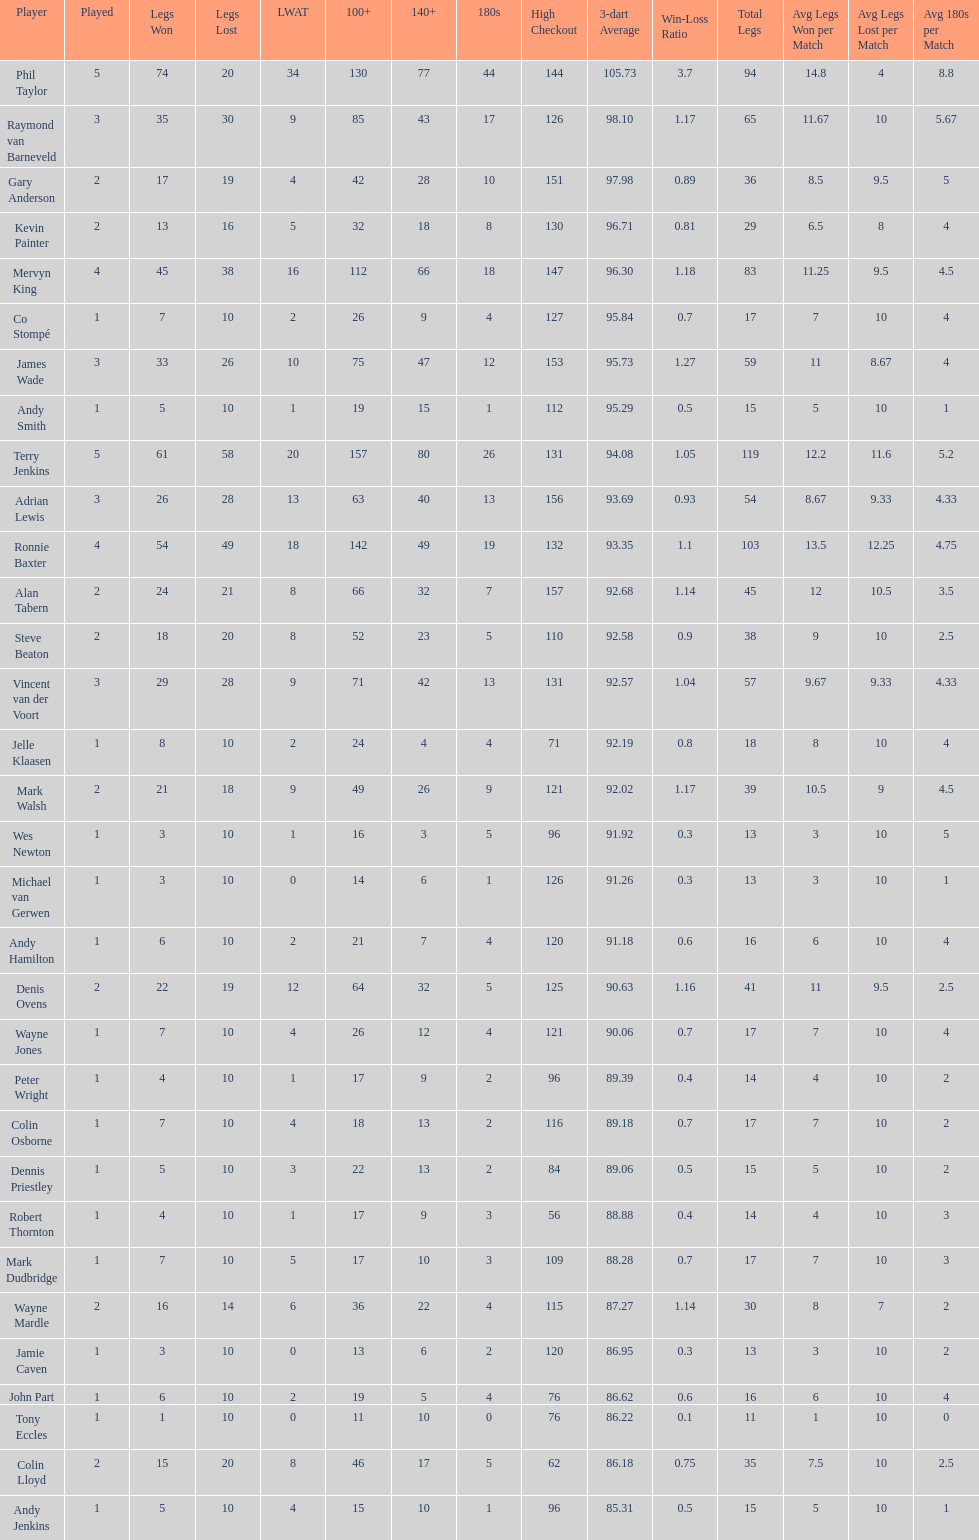What is the total amount of players who played more than 3 games? 4. 